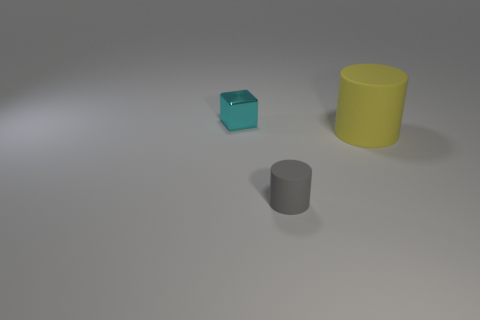Subtract all cylinders. How many objects are left? 1 Add 2 tiny green matte cylinders. How many objects exist? 5 Subtract all cubes. Subtract all small purple balls. How many objects are left? 2 Add 3 gray things. How many gray things are left? 4 Add 3 shiny cubes. How many shiny cubes exist? 4 Subtract 1 cyan blocks. How many objects are left? 2 